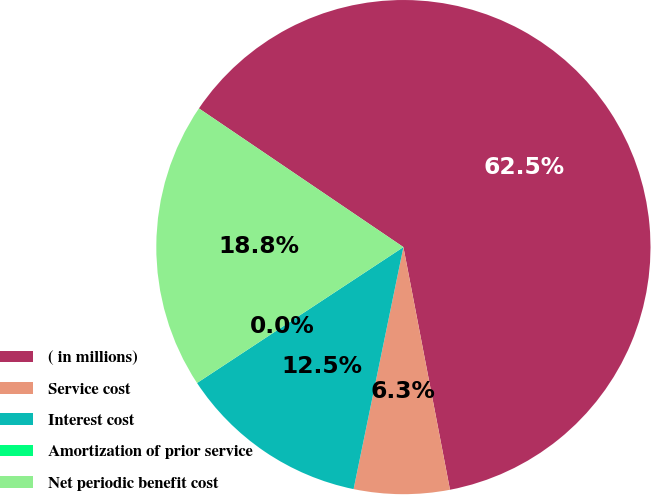<chart> <loc_0><loc_0><loc_500><loc_500><pie_chart><fcel>( in millions)<fcel>Service cost<fcel>Interest cost<fcel>Amortization of prior service<fcel>Net periodic benefit cost<nl><fcel>62.49%<fcel>6.25%<fcel>12.5%<fcel>0.0%<fcel>18.75%<nl></chart> 